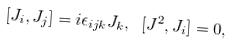<formula> <loc_0><loc_0><loc_500><loc_500>[ J _ { i } , J _ { j } ] = i \epsilon _ { i j k } J _ { k } , \ [ J ^ { 2 } , J _ { i } ] = 0 ,</formula> 